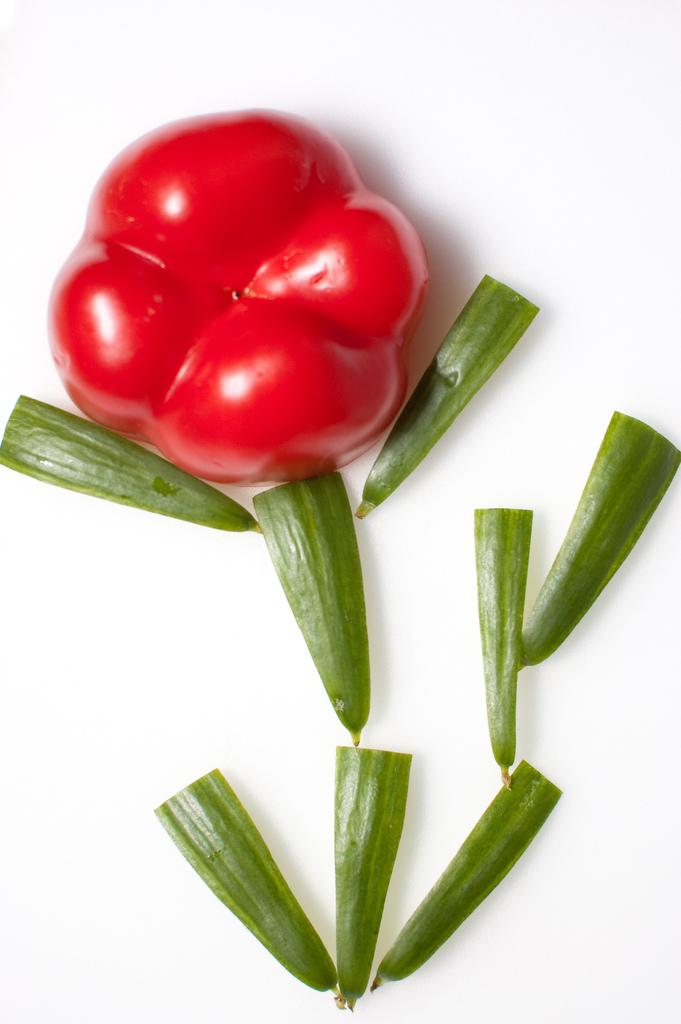What type of food can be seen in the image? There are slices of capsicum and other vegetables in the image. Can you describe the other vegetables present in the image? Unfortunately, the specific types of other vegetables cannot be determined from the provided facts. How many steps does it take for the vegetables to walk across the image? Vegetables do not have the ability to walk, so this question cannot be answered. 